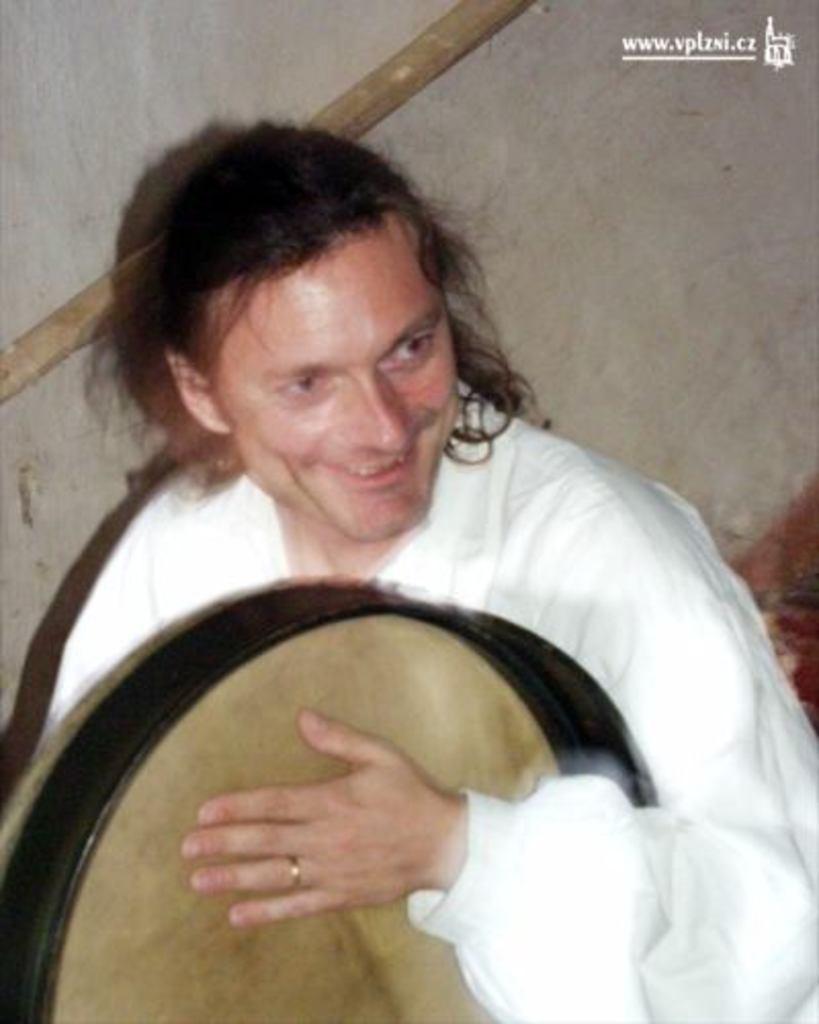Could you give a brief overview of what you see in this image? A man is holding the drum, he is smiling. He wore a white color dress. 